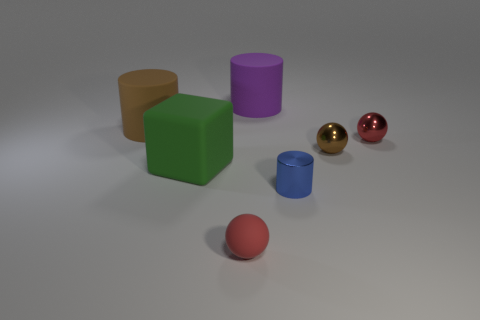Do the block and the cylinder to the left of the big green object have the same size?
Provide a short and direct response. Yes. Is there anything else that is the same shape as the large green object?
Your answer should be very brief. No. How many big brown matte things are there?
Offer a very short reply. 1. What number of blue objects are either matte things or tiny balls?
Give a very brief answer. 0. Do the large cylinder that is on the left side of the large block and the big green thing have the same material?
Ensure brevity in your answer.  Yes. What number of other objects are the same material as the big purple thing?
Give a very brief answer. 3. What material is the blue thing?
Provide a succinct answer. Metal. How big is the brown thing that is to the left of the blue metallic thing?
Your response must be concise. Large. There is a tiny sphere in front of the tiny blue shiny object; how many rubber cylinders are on the right side of it?
Make the answer very short. 1. There is a small thing left of the tiny shiny cylinder; does it have the same shape as the big matte thing that is on the right side of the green cube?
Ensure brevity in your answer.  No. 